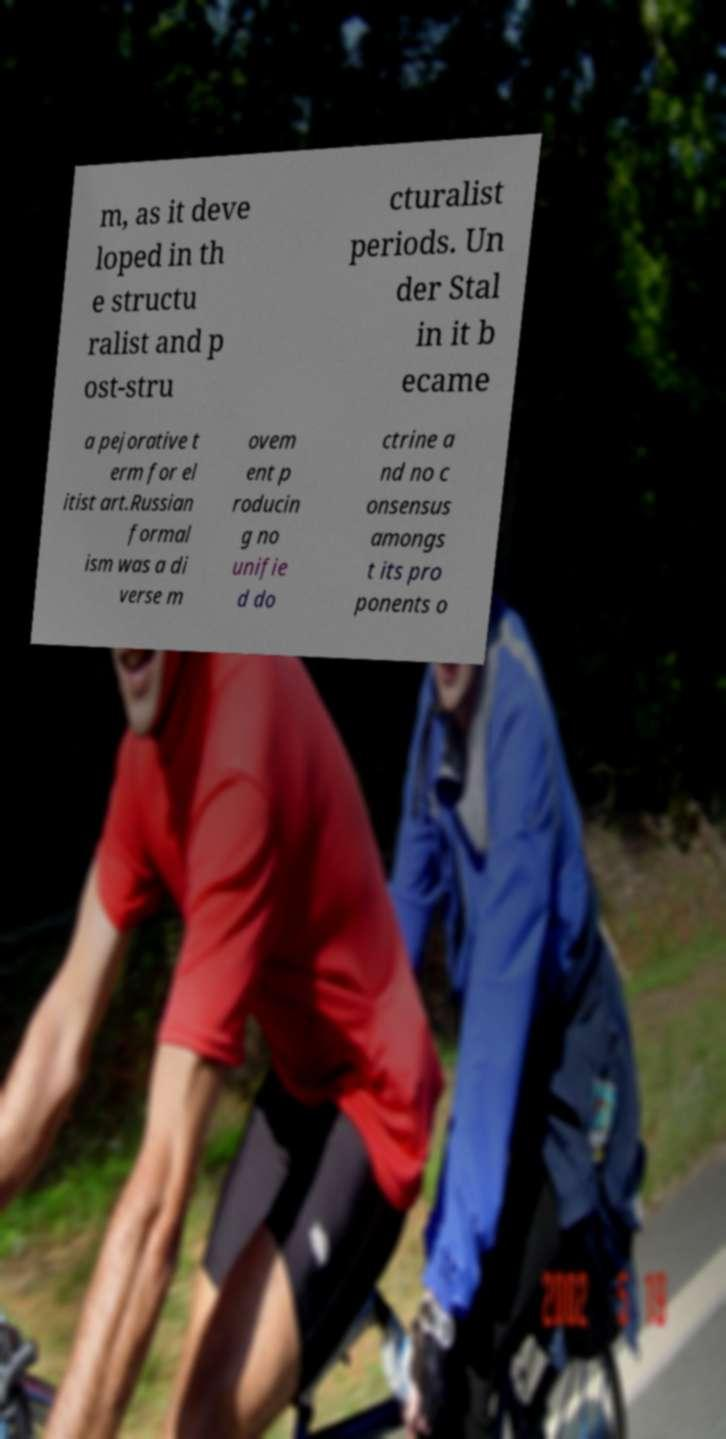Could you assist in decoding the text presented in this image and type it out clearly? m, as it deve loped in th e structu ralist and p ost-stru cturalist periods. Un der Stal in it b ecame a pejorative t erm for el itist art.Russian formal ism was a di verse m ovem ent p roducin g no unifie d do ctrine a nd no c onsensus amongs t its pro ponents o 